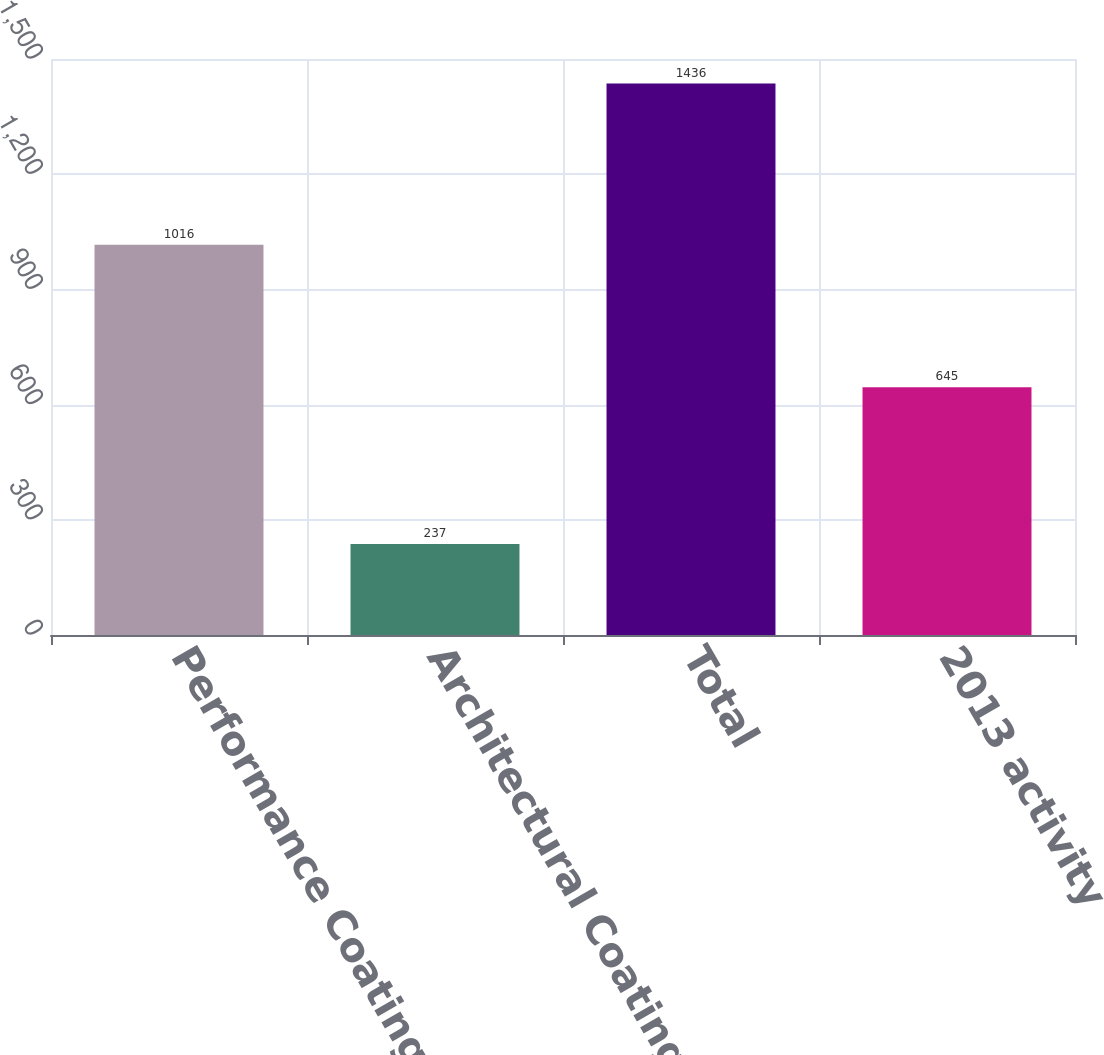<chart> <loc_0><loc_0><loc_500><loc_500><bar_chart><fcel>Performance Coatings<fcel>Architectural Coatings - EMEA<fcel>Total<fcel>2013 activity<nl><fcel>1016<fcel>237<fcel>1436<fcel>645<nl></chart> 